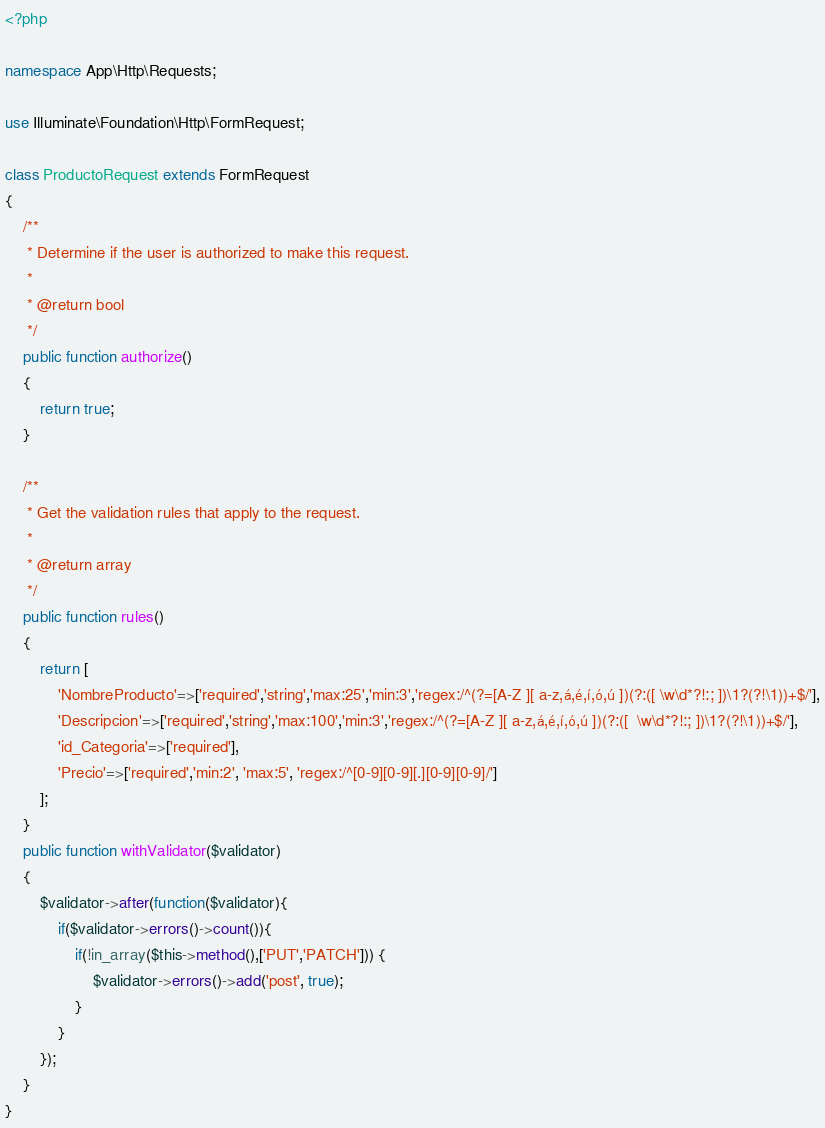<code> <loc_0><loc_0><loc_500><loc_500><_PHP_><?php

namespace App\Http\Requests;

use Illuminate\Foundation\Http\FormRequest;

class ProductoRequest extends FormRequest
{
    /**
     * Determine if the user is authorized to make this request.
     *
     * @return bool
     */
    public function authorize()
    {
        return true;
    }

    /**
     * Get the validation rules that apply to the request.
     *
     * @return array
     */
    public function rules()
    {
        return [
            'NombreProducto'=>['required','string','max:25','min:3','regex:/^(?=[A-Z ][ a-z,á,é,í,ó,ú ])(?:([ \w\d*?!:; ])\1?(?!\1))+$/'],
            'Descripcion'=>['required','string','max:100','min:3','regex:/^(?=[A-Z ][ a-z,á,é,í,ó,ú ])(?:([  \w\d*?!:; ])\1?(?!\1))+$/'],
            'id_Categoria'=>['required'],
            'Precio'=>['required','min:2', 'max:5', 'regex:/^[0-9][0-9][.][0-9][0-9]/']
        ];
    }
    public function withValidator($validator)
    {
        $validator->after(function($validator){
            if($validator->errors()->count()){
                if(!in_array($this->method(),['PUT','PATCH'])) {
                    $validator->errors()->add('post', true);
                }
            }
        });
    }
}
</code> 